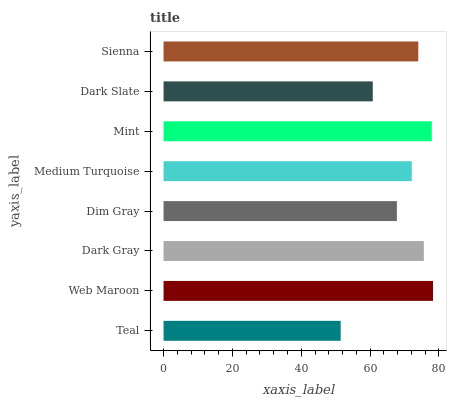Is Teal the minimum?
Answer yes or no. Yes. Is Web Maroon the maximum?
Answer yes or no. Yes. Is Dark Gray the minimum?
Answer yes or no. No. Is Dark Gray the maximum?
Answer yes or no. No. Is Web Maroon greater than Dark Gray?
Answer yes or no. Yes. Is Dark Gray less than Web Maroon?
Answer yes or no. Yes. Is Dark Gray greater than Web Maroon?
Answer yes or no. No. Is Web Maroon less than Dark Gray?
Answer yes or no. No. Is Sienna the high median?
Answer yes or no. Yes. Is Medium Turquoise the low median?
Answer yes or no. Yes. Is Mint the high median?
Answer yes or no. No. Is Dim Gray the low median?
Answer yes or no. No. 